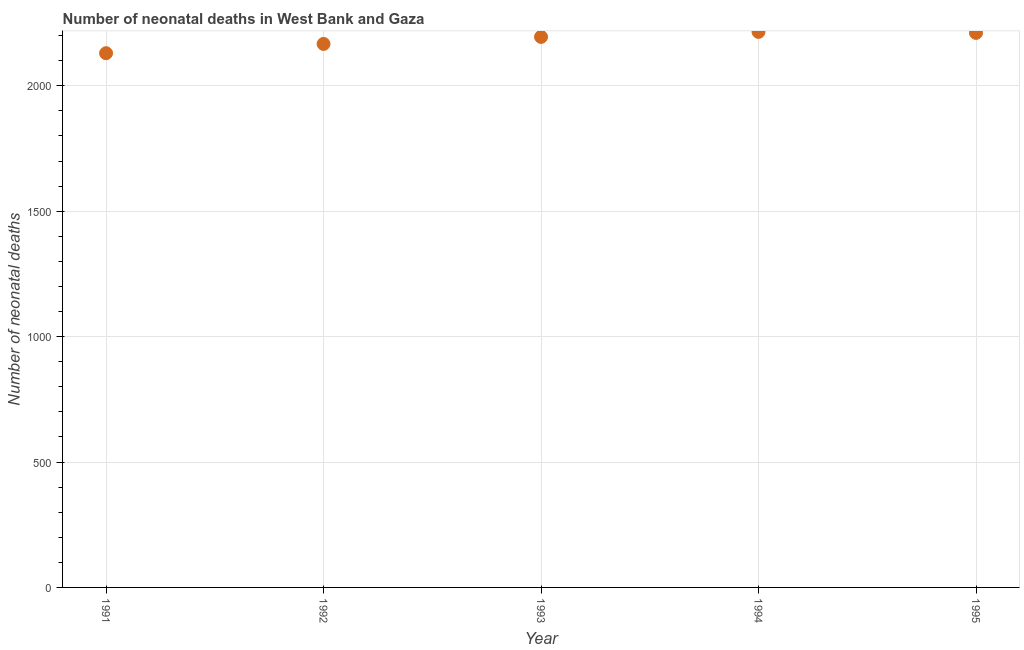What is the number of neonatal deaths in 1991?
Provide a succinct answer. 2130. Across all years, what is the maximum number of neonatal deaths?
Your response must be concise. 2215. Across all years, what is the minimum number of neonatal deaths?
Offer a very short reply. 2130. In which year was the number of neonatal deaths maximum?
Make the answer very short. 1994. In which year was the number of neonatal deaths minimum?
Your answer should be very brief. 1991. What is the sum of the number of neonatal deaths?
Offer a very short reply. 1.09e+04. What is the difference between the number of neonatal deaths in 1992 and 1993?
Ensure brevity in your answer.  -28. What is the average number of neonatal deaths per year?
Keep it short and to the point. 2183.6. What is the median number of neonatal deaths?
Your answer should be very brief. 2195. What is the ratio of the number of neonatal deaths in 1994 to that in 1995?
Ensure brevity in your answer.  1. Is the number of neonatal deaths in 1991 less than that in 1994?
Make the answer very short. Yes. What is the difference between the highest and the second highest number of neonatal deaths?
Make the answer very short. 4. What is the difference between the highest and the lowest number of neonatal deaths?
Provide a succinct answer. 85. How many years are there in the graph?
Ensure brevity in your answer.  5. Does the graph contain any zero values?
Keep it short and to the point. No. What is the title of the graph?
Offer a terse response. Number of neonatal deaths in West Bank and Gaza. What is the label or title of the X-axis?
Offer a very short reply. Year. What is the label or title of the Y-axis?
Provide a short and direct response. Number of neonatal deaths. What is the Number of neonatal deaths in 1991?
Your response must be concise. 2130. What is the Number of neonatal deaths in 1992?
Offer a very short reply. 2167. What is the Number of neonatal deaths in 1993?
Provide a short and direct response. 2195. What is the Number of neonatal deaths in 1994?
Make the answer very short. 2215. What is the Number of neonatal deaths in 1995?
Make the answer very short. 2211. What is the difference between the Number of neonatal deaths in 1991 and 1992?
Make the answer very short. -37. What is the difference between the Number of neonatal deaths in 1991 and 1993?
Keep it short and to the point. -65. What is the difference between the Number of neonatal deaths in 1991 and 1994?
Your answer should be very brief. -85. What is the difference between the Number of neonatal deaths in 1991 and 1995?
Your answer should be very brief. -81. What is the difference between the Number of neonatal deaths in 1992 and 1993?
Offer a very short reply. -28. What is the difference between the Number of neonatal deaths in 1992 and 1994?
Your answer should be very brief. -48. What is the difference between the Number of neonatal deaths in 1992 and 1995?
Provide a succinct answer. -44. What is the difference between the Number of neonatal deaths in 1994 and 1995?
Keep it short and to the point. 4. What is the ratio of the Number of neonatal deaths in 1991 to that in 1992?
Offer a terse response. 0.98. What is the ratio of the Number of neonatal deaths in 1991 to that in 1993?
Your answer should be compact. 0.97. What is the ratio of the Number of neonatal deaths in 1991 to that in 1994?
Your response must be concise. 0.96. What is the ratio of the Number of neonatal deaths in 1991 to that in 1995?
Your answer should be very brief. 0.96. What is the ratio of the Number of neonatal deaths in 1992 to that in 1993?
Offer a terse response. 0.99. What is the ratio of the Number of neonatal deaths in 1992 to that in 1994?
Provide a succinct answer. 0.98. What is the ratio of the Number of neonatal deaths in 1992 to that in 1995?
Provide a short and direct response. 0.98. What is the ratio of the Number of neonatal deaths in 1993 to that in 1994?
Ensure brevity in your answer.  0.99. What is the ratio of the Number of neonatal deaths in 1994 to that in 1995?
Provide a succinct answer. 1. 